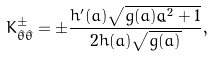<formula> <loc_0><loc_0><loc_500><loc_500>K _ { \hat { \theta } \hat { \theta } } ^ { \pm } = \pm \frac { h ^ { \prime } ( a ) \sqrt { g ( a ) \dot { a } ^ { 2 } + 1 } } { 2 h ( a ) \sqrt { g ( a ) } } ,</formula> 